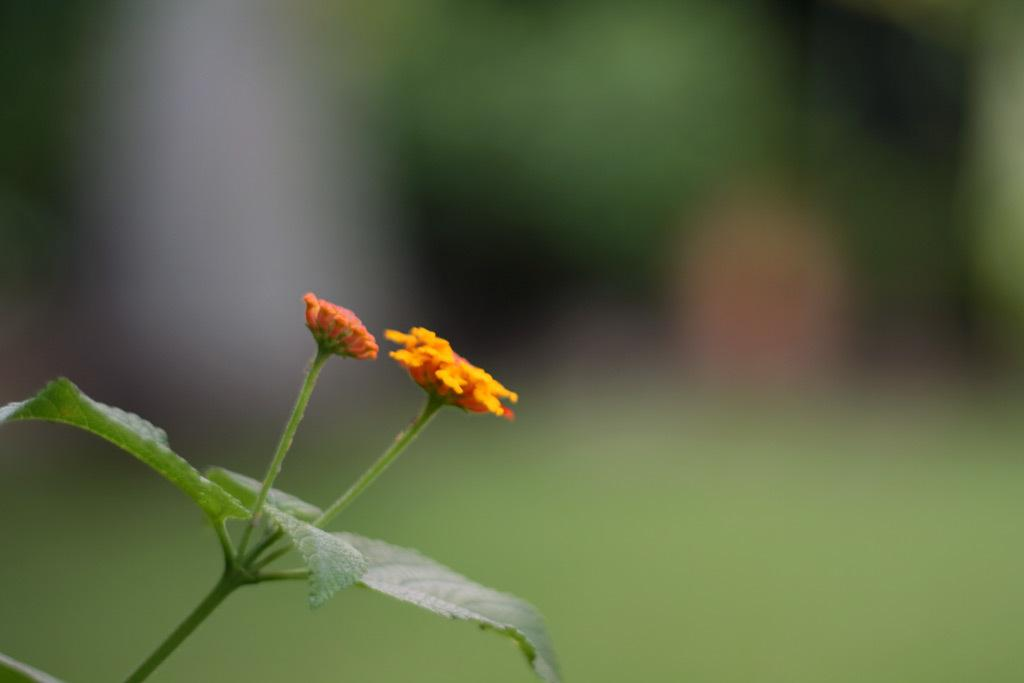What type of plant elements can be seen in the image? There are flowers, leaves, and stems in the image. Can you describe the background of the image? The background of the image is blurry. What invention is being demonstrated in the image? There is no invention being demonstrated in the image; it features flowers, leaves, and stems. How does the image depict the level of pollution in the area? The image does not depict the level of pollution; it only shows flowers, leaves, and stems. 